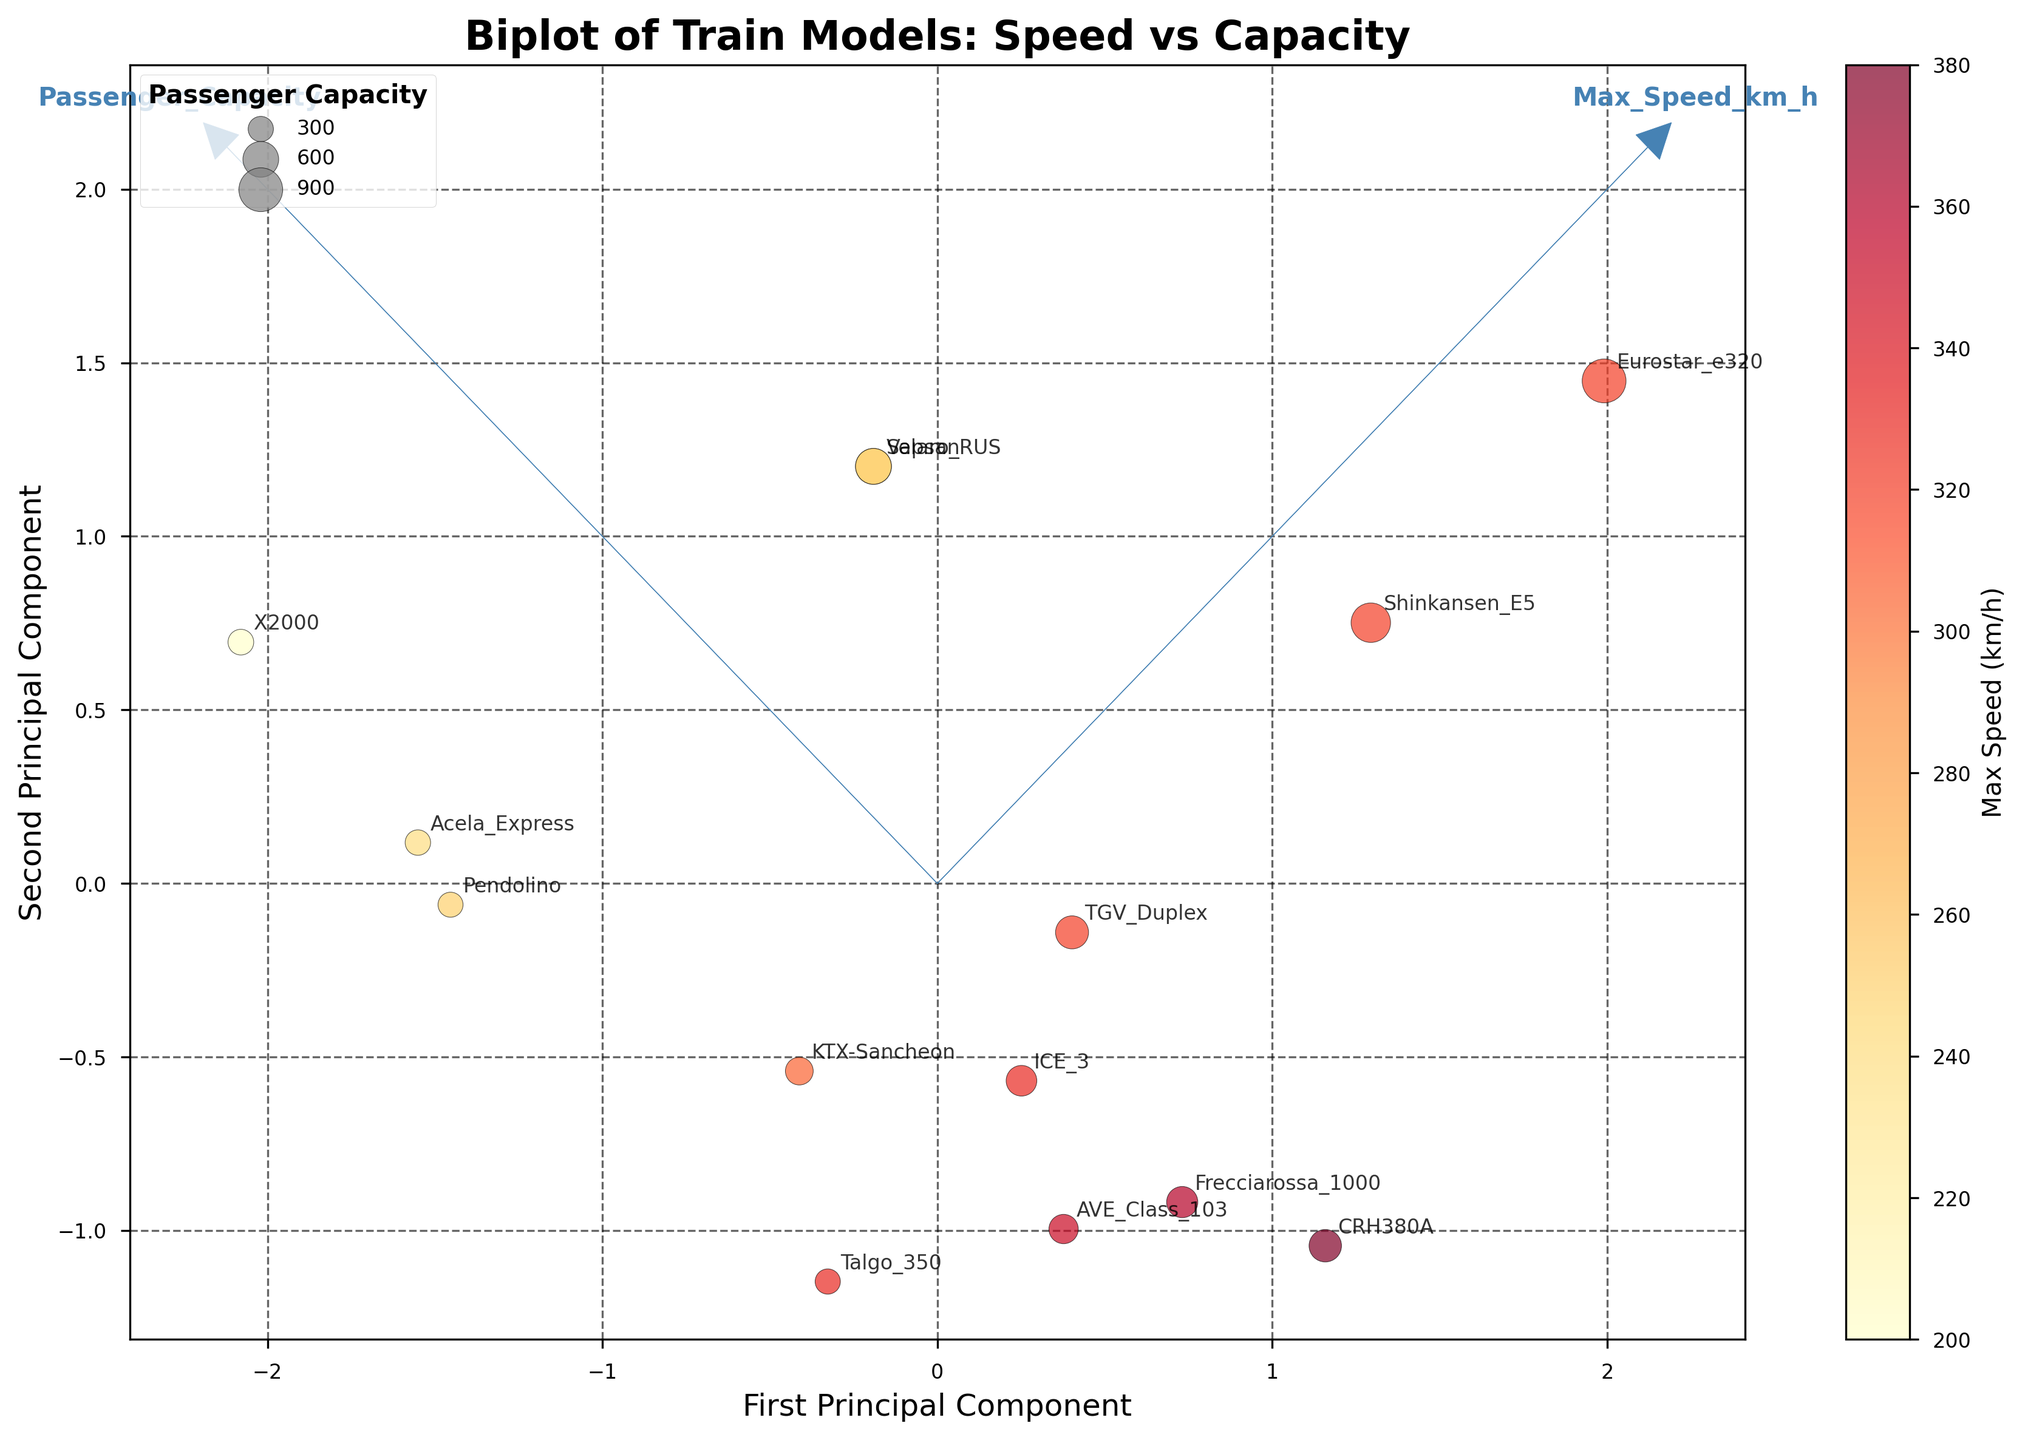How many locomotives are displayed in the plot? Count the distinct data points on the plot; each represents a different locomotive model.
Answer: 14 What do the axes labels 'First Principal Component' and 'Second Principal Component' refer to? These labels refer to the two main components that capture the most variance in the data after performing PCA (Principal Component Analysis).
Answer: Principal components Which train model appears to have the highest speed? Identify the train model with the highest maximum speed based on the color scale of the data points.
Answer: CRH380A Which feature vectors are displayed in the plot? The arrows represent the feature vectors for Max Speed (km/h) and Passenger Capacity, indicating the direction and significance of these features in the PCA space.
Answer: Max Speed, Passenger Capacity Which locomotive has the largest passenger capacity? Find the data point with the largest bubble size, as bubble size correlates with passenger capacity.
Answer: Eurostar e320 Which train models have a maximum speed of 250 km/h? Look at the color bar and identify the data points with a color corresponding to 250 km/h; then check the labels of those points.
Answer: Velaro RUS, Sapsan, Pendolino What can you infer about the relationship between speed and passenger capacity for most trains? Observe the general direction of the feature vectors and how data points are spread relative to these vectors to understand the correlation between speed and capacity.
Answer: Weak positive correlation Compare the first and second principal components for ICE 3 and Acela Express. Which component contributes more to the variance for each model? Check the position of ICE 3 and Acela Express in the PCA space to determine whether they align more closely with the first or second principal component.
Answer: First for both Which train has the smallest passenger capacity and what is its maximum speed? Identify the smallest bubble on the plot, annotate its label, and check its color for speed.
Answer: Talgo 350, 330 km/h 